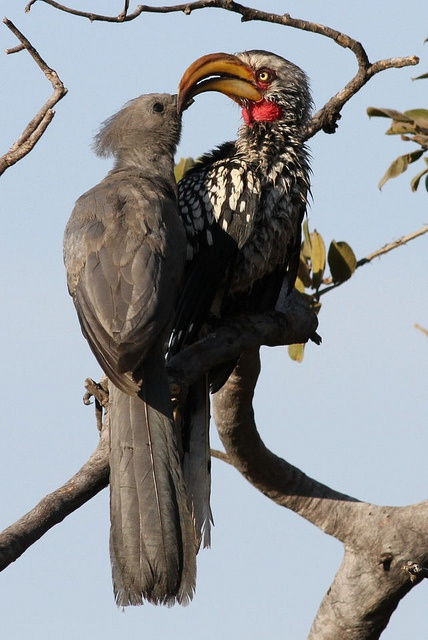Describe the objects in this image and their specific colors. I can see bird in lightblue, black, gray, maroon, and brown tones and bird in lightblue, black, and gray tones in this image. 